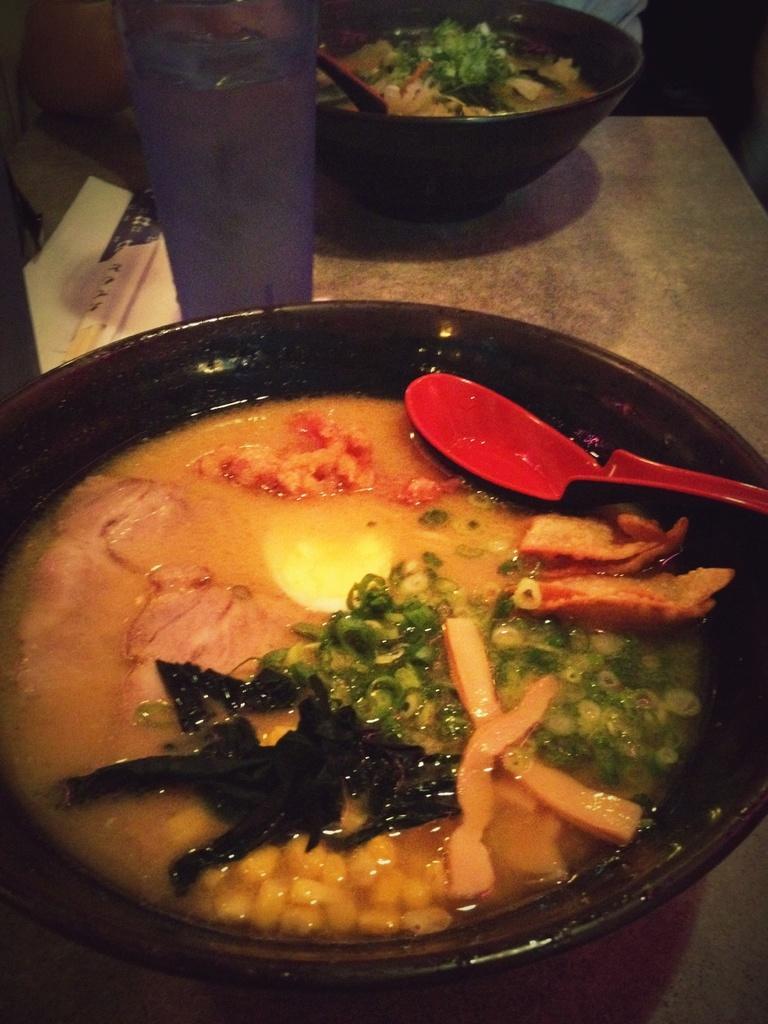Could you give a brief overview of what you see in this image? This image is taken indoors. At the bottom of the image there is a table with two bowls of food, two spoons and a glass of water on it. At the top of the image there is a person. 